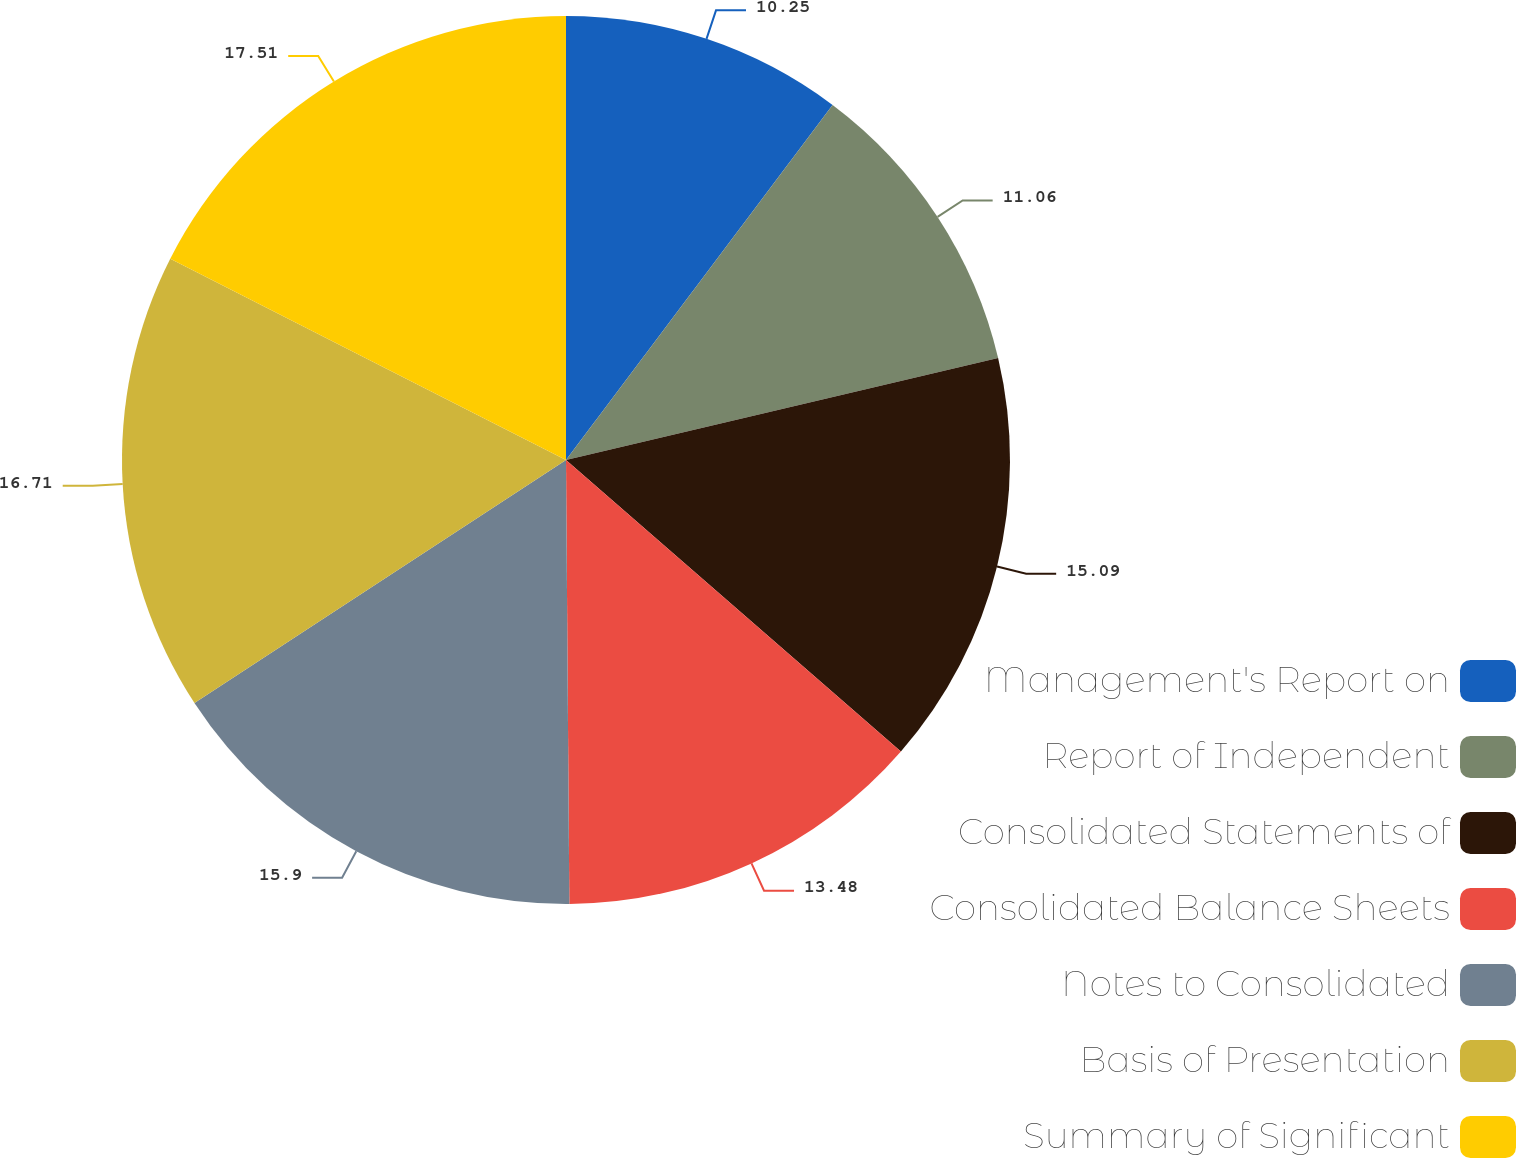<chart> <loc_0><loc_0><loc_500><loc_500><pie_chart><fcel>Management's Report on<fcel>Report of Independent<fcel>Consolidated Statements of<fcel>Consolidated Balance Sheets<fcel>Notes to Consolidated<fcel>Basis of Presentation<fcel>Summary of Significant<nl><fcel>10.25%<fcel>11.06%<fcel>15.09%<fcel>13.48%<fcel>15.9%<fcel>16.71%<fcel>17.51%<nl></chart> 